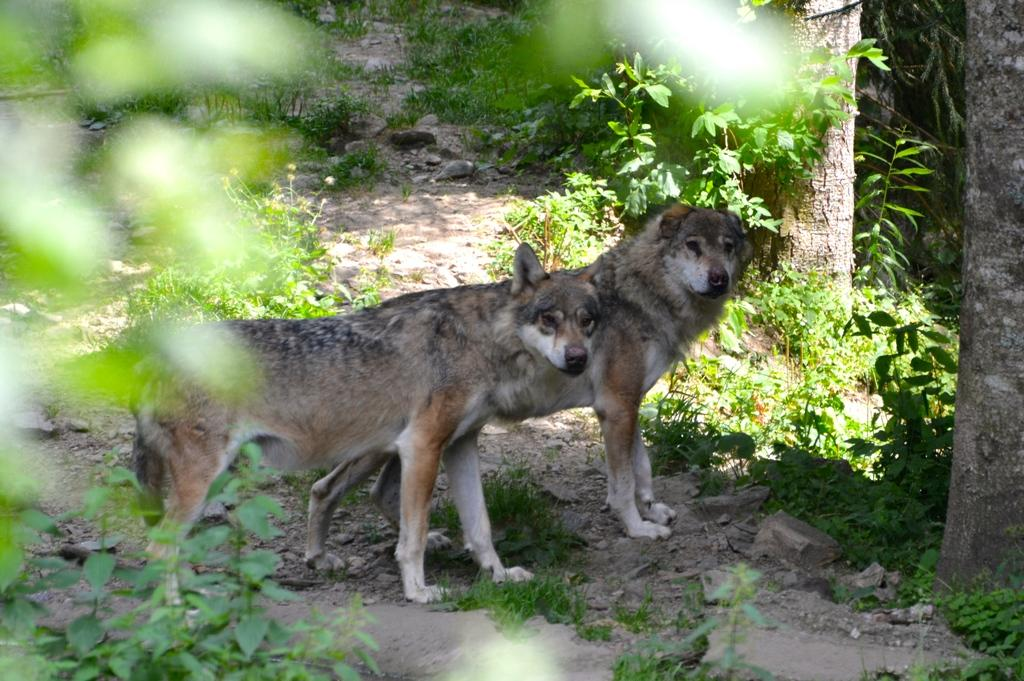How many wolves are in the image? There are two wolves in the image. What is the wolves' position in relation to the ground? The wolves are standing on the ground. What type of vegetation can be seen on the right side of the image? There are two trees on the right side of the image. What other features can be observed on the ground? Small plants and stones are visible on the ground. What is the beggar's belief about the art in the image? There is no beggar or art present in the image; it features two wolves standing on the ground with trees, small plants, and stones. 